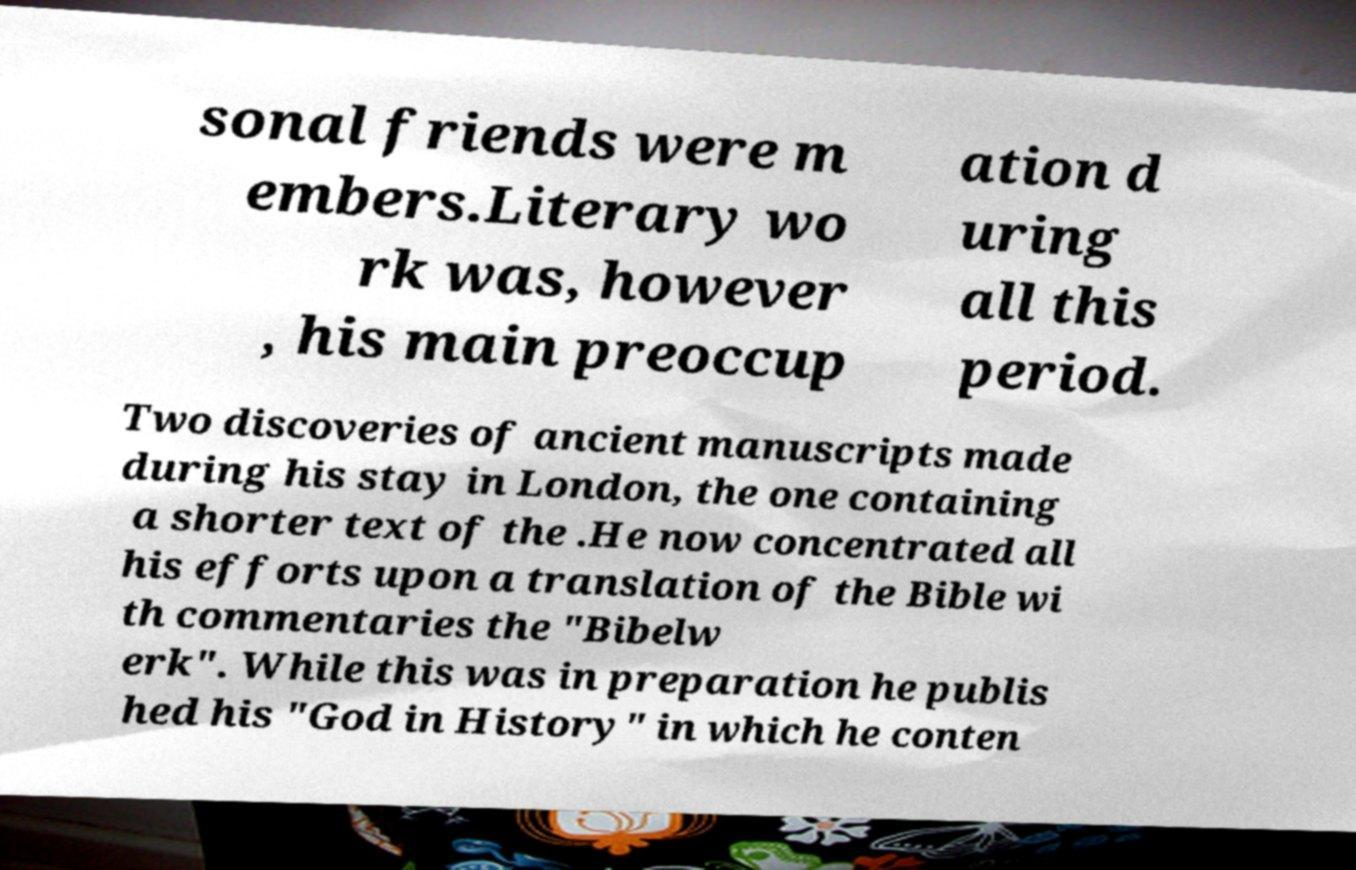I need the written content from this picture converted into text. Can you do that? sonal friends were m embers.Literary wo rk was, however , his main preoccup ation d uring all this period. Two discoveries of ancient manuscripts made during his stay in London, the one containing a shorter text of the .He now concentrated all his efforts upon a translation of the Bible wi th commentaries the "Bibelw erk". While this was in preparation he publis hed his "God in History" in which he conten 